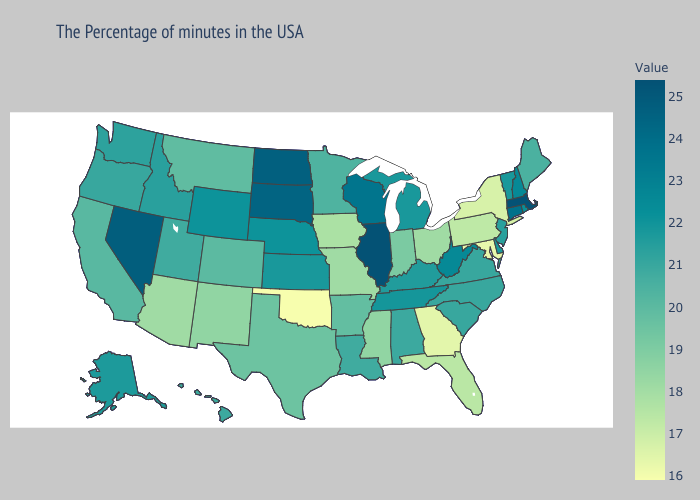Does Oregon have a higher value than Nebraska?
Short answer required. No. Does Wisconsin have a higher value than Nevada?
Quick response, please. No. 